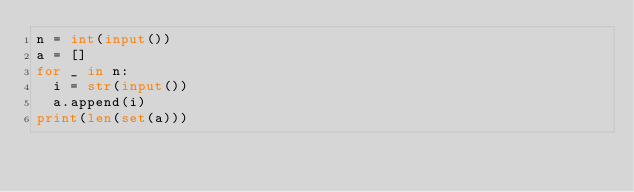Convert code to text. <code><loc_0><loc_0><loc_500><loc_500><_Python_>n = int(input())
a = []
for _ in n:
  i = str(input())
  a.append(i)
print(len(set(a)))  </code> 